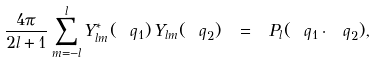<formula> <loc_0><loc_0><loc_500><loc_500>\frac { 4 \pi } { 2 l + 1 } \sum _ { m = - l } ^ { l } Y _ { l m } ^ { * } ( \ q _ { 1 } ) \, Y _ { l m } ( \ q _ { 2 } ) \ = \ P _ { l } ( \ q _ { 1 } \cdot \ q _ { 2 } ) ,</formula> 